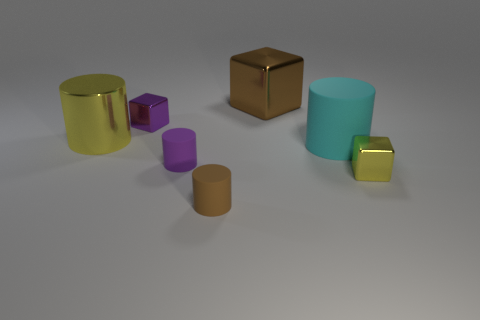Subtract all big yellow metal cylinders. How many cylinders are left? 3 Subtract all cubes. How many objects are left? 4 Add 1 big gray shiny blocks. How many objects exist? 8 Subtract all purple cylinders. How many cylinders are left? 3 Subtract 4 cylinders. How many cylinders are left? 0 Subtract 0 green cylinders. How many objects are left? 7 Subtract all red blocks. Subtract all cyan balls. How many blocks are left? 3 Subtract all cylinders. Subtract all tiny balls. How many objects are left? 3 Add 5 small rubber objects. How many small rubber objects are left? 7 Add 3 cyan matte cylinders. How many cyan matte cylinders exist? 4 